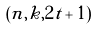<formula> <loc_0><loc_0><loc_500><loc_500>( n , k , 2 t + 1 )</formula> 